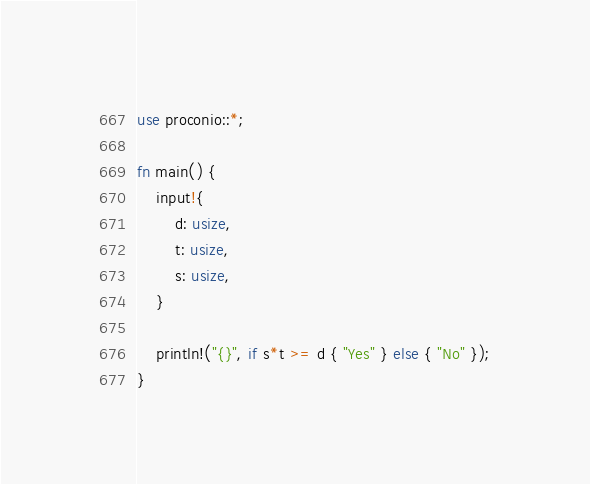<code> <loc_0><loc_0><loc_500><loc_500><_Rust_>use proconio::*;

fn main() {
    input!{
        d: usize,
        t: usize,
        s: usize,
    }

    println!("{}", if s*t >= d { "Yes" } else { "No" });
}
</code> 